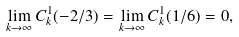<formula> <loc_0><loc_0><loc_500><loc_500>\lim _ { k \to \infty } C ^ { 1 } _ { k } ( - 2 / 3 ) = \lim _ { k \to \infty } C ^ { 1 } _ { k } ( 1 / 6 ) = 0 ,</formula> 